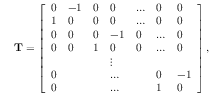<formula> <loc_0><loc_0><loc_500><loc_500>\mathbf T = \left [ \begin{array} { l l l l l l l } { 0 } & { - 1 } & { 0 } & { 0 } & { \dots } & { 0 } & { 0 } \\ { 1 } & { 0 } & { 0 } & { 0 } & { \dots } & { 0 } & { 0 } \\ { 0 } & { 0 } & { 0 } & { - 1 } & { 0 } & { \dots } & { 0 } \\ { 0 } & { 0 } & { 1 } & { 0 } & { 0 } & { \dots } & { 0 } \\ & & & { \vdots } \\ { 0 } & & & { \dots } & & { 0 } & { - 1 } \\ { 0 } & & & { \dots } & & { 1 } & { 0 } \end{array} \right ] ,</formula> 